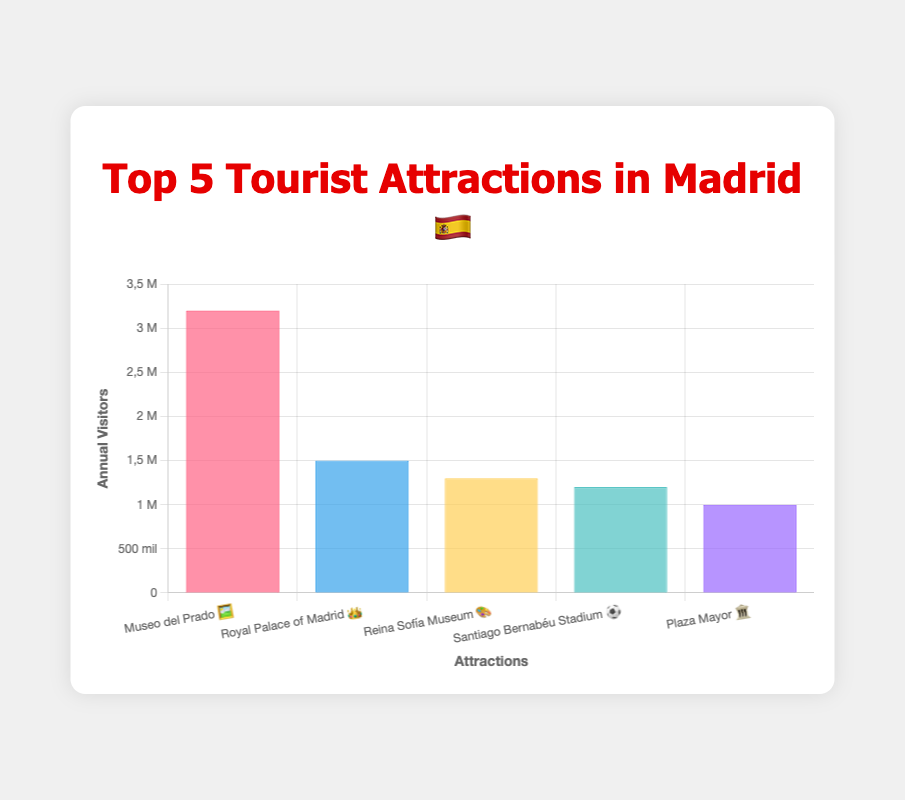Which tourist attraction in Madrid has the highest number of annual visitors? The Museo del Prado 🖼️ has the highest number of annual visitors, with a visitor count of 3,200,000, which is the tallest bar in the bar chart.
Answer: Museo del Prado 🖼️ What's the total number of visitors for the top 5 attractions combined? To find the total, we sum the visitor numbers for all five attractions: 3,200,000 (Museo del Prado) + 1,500,000 (Royal Palace of Madrid) + 1,300,000 (Reina Sofía Museum) + 1,200,000 (Santiago Bernabéu Stadium) + 1,000,000 (Plaza Mayor) = 8,200,000.
Answer: 8,200,000 Which attraction has the least number of annual visitors? The Plaza Mayor 🏛️ has the lowest number of annual visitors, with a visitor count of 1,000,000, which is the shortest bar in the bar chart.
Answer: Plaza Mayor 🏛️ How many more visitors does the Museo del Prado 🖼️ have compared to the Santiago Bernabéu Stadium ⚽? The Museo del Prado has 3,200,000 visitors and the Santiago Bernabéu Stadium has 1,200,000 visitors. The difference is 3,200,000 - 1,200,000 = 2,000,000 more visitors.
Answer: 2,000,000 Which attractions have more than 1,000,000 annual visitors? Each bar representing the number of annual visitors for Museo del Prado 🖼️, Royal Palace of Madrid 👑, Reina Sofía Museum 🎨, and Santiago Bernabéu Stadium ⚽ exceed the 1,000,000 mark. The bars for these attractions all have values above the 1,000,000 tick on the y-axis.
Answer: Museo del Prado 🖼️, Royal Palace of Madrid 👑, Reina Sofía Museum 🎨, Santiago Bernabéu Stadium ⚽ What's the average number of annual visitors for these top 5 attractions? Sum the visitors for all five attractions and divide by 5: (3,200,000 + 1,500,000 + 1,300,000 + 1,200,000 + 1,000,000) / 5 = 8,200,000 / 5 = 1,640,000.
Answer: 1,640,000 By how much does the Royal Palace of Madrid 👑 exceed the Plaza Mayor 🏛️ in annual visitors? The Royal Palace of Madrid has 1,500,000 visitors and the Plaza Mayor has 1,000,000 visitors. The difference is 1,500,000 - 1,000,000 = 500,000 more visitors.
Answer: 500,000 